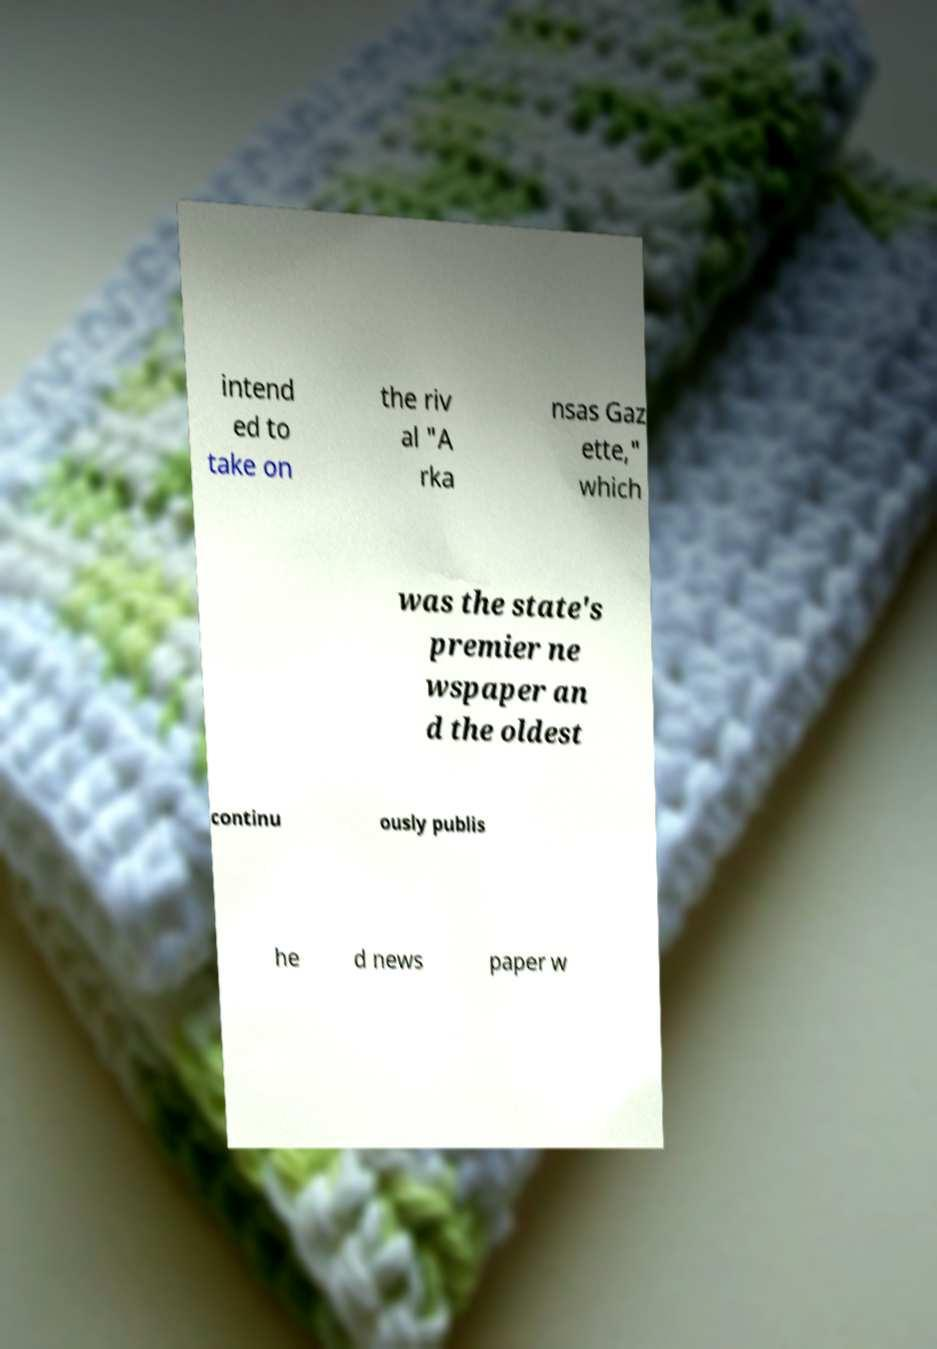Can you accurately transcribe the text from the provided image for me? intend ed to take on the riv al "A rka nsas Gaz ette," which was the state's premier ne wspaper an d the oldest continu ously publis he d news paper w 